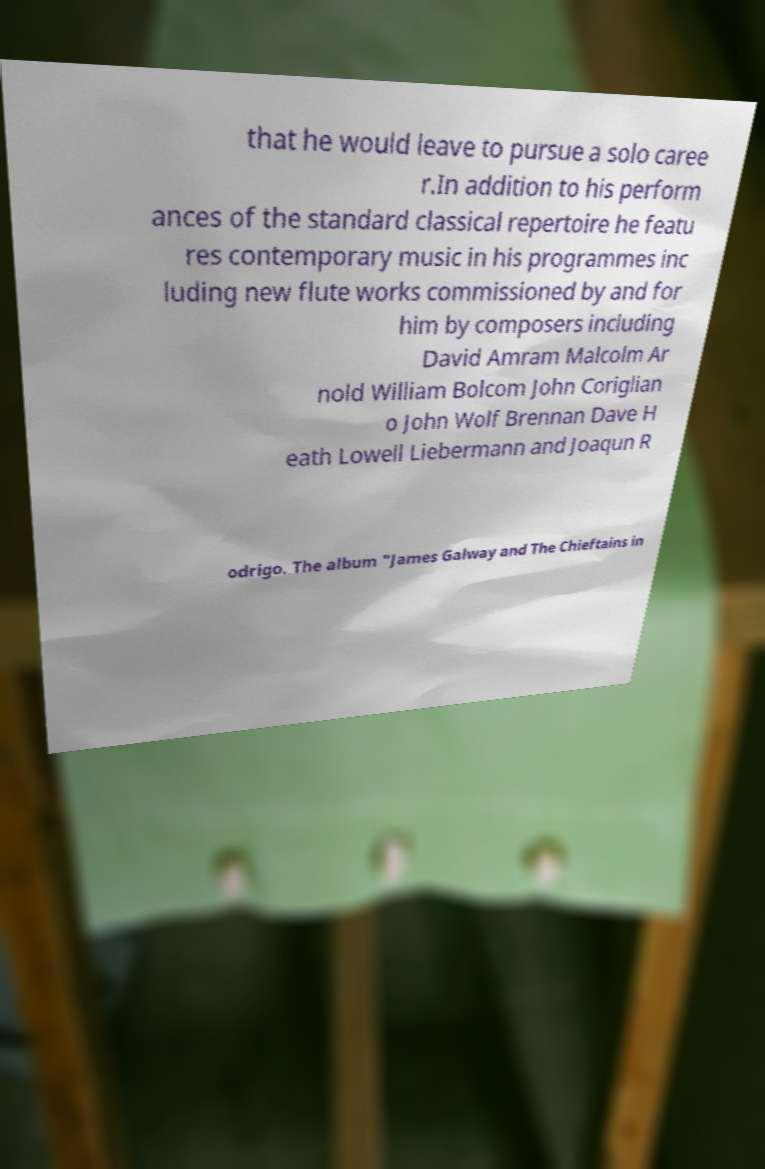Can you read and provide the text displayed in the image?This photo seems to have some interesting text. Can you extract and type it out for me? that he would leave to pursue a solo caree r.In addition to his perform ances of the standard classical repertoire he featu res contemporary music in his programmes inc luding new flute works commissioned by and for him by composers including David Amram Malcolm Ar nold William Bolcom John Coriglian o John Wolf Brennan Dave H eath Lowell Liebermann and Joaqun R odrigo. The album "James Galway and The Chieftains in 